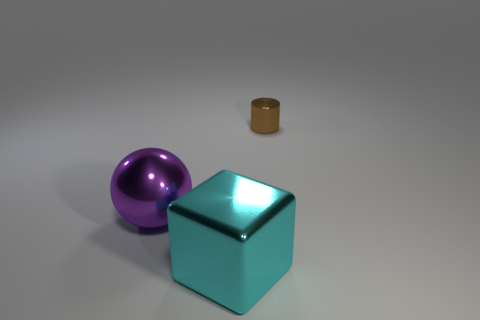There is a brown object; how many cyan metallic cubes are to the right of it?
Provide a succinct answer. 0. Are any cylinders visible?
Provide a short and direct response. Yes. There is a thing to the right of the object in front of the large shiny object that is behind the metallic cube; what is its size?
Provide a short and direct response. Small. What number of other things are there of the same size as the cyan metal block?
Your answer should be very brief. 1. There is a metallic object to the left of the cyan shiny thing; what size is it?
Your answer should be very brief. Large. Is there anything else that has the same color as the small thing?
Offer a very short reply. No. Do the big thing that is right of the purple object and the small brown object have the same material?
Your answer should be compact. Yes. What number of metallic things are behind the cyan cube and in front of the tiny brown metallic cylinder?
Your answer should be very brief. 1. There is a purple metallic thing that is left of the big object on the right side of the purple shiny sphere; how big is it?
Make the answer very short. Large. Is there any other thing that is made of the same material as the small cylinder?
Offer a terse response. Yes. 